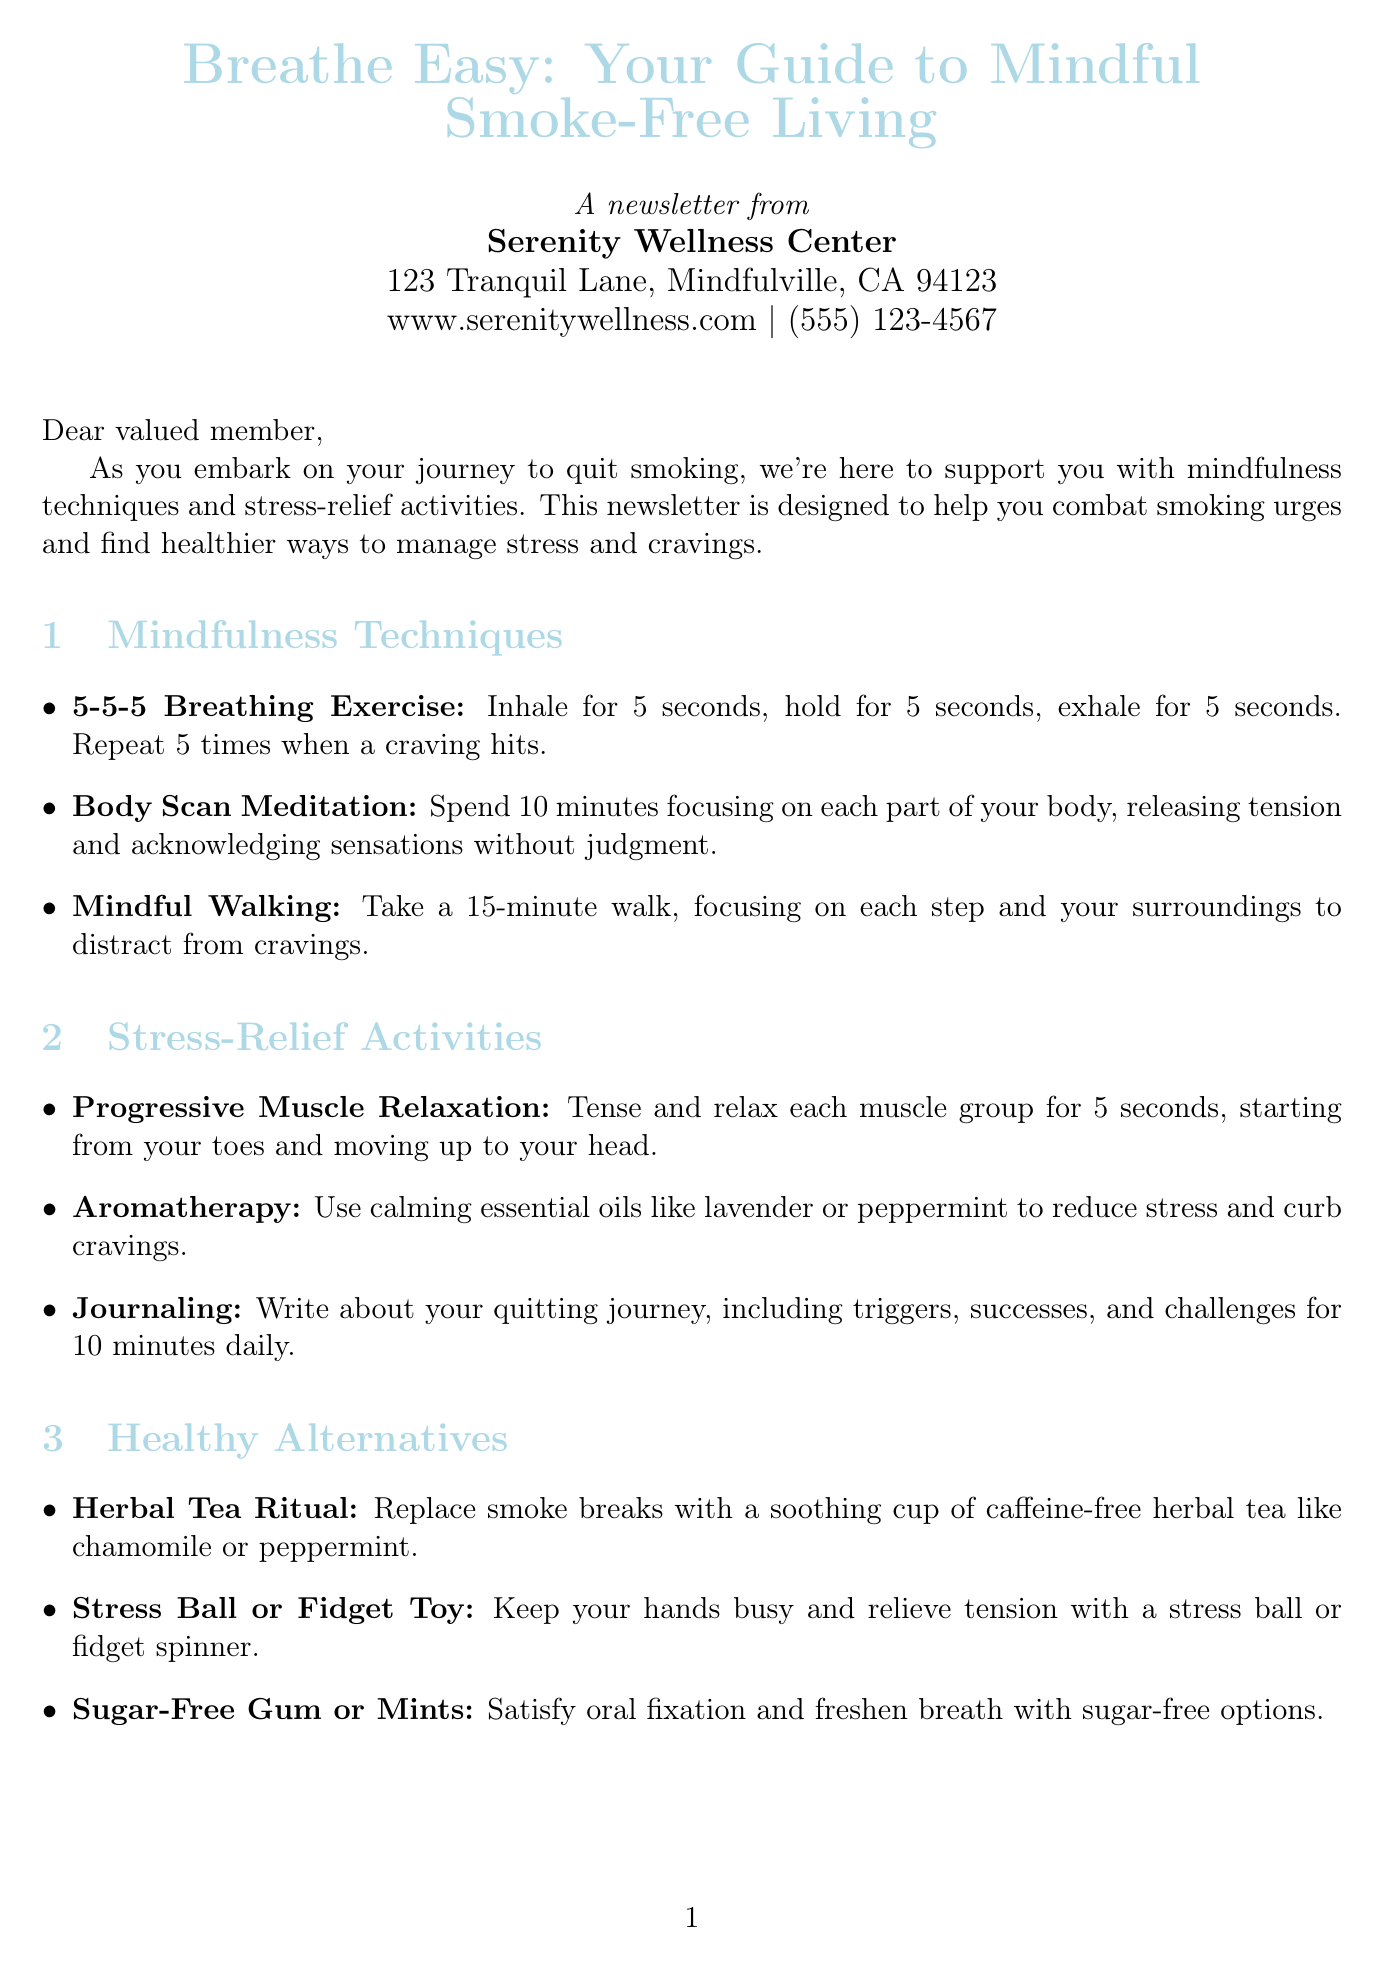What is the title of the newsletter? The title of the newsletter is mentioned at the beginning of the document.
Answer: Breathe Easy: Your Guide to Mindful Smoke-Free Living Who is the editor of the newsletter? The document identifies the editor's name and title.
Answer: Dr. Emma Thompson What is the location of the Serenity Wellness Center? The address of the center is provided in the document.
Answer: 123 Tranquil Lane, Mindfulville, CA 94123 What is the frequency of the Quit Smoking Support Group? The document states how often the support group meets.
Answer: Every Tuesday What activity is suggested to replace smoke breaks? The document lists healthier alternatives to smoking.
Answer: Herbal Tea Ritual Which breathing exercise is mentioned first? The mindfulness techniques are listed in the document, and the first one is specified.
Answer: 5-5-5 Breathing Exercise On which day and time is the Stress-Relief Yoga Class held? This detail can be found in the section about upcoming events.
Answer: Mondays and Thursdays at 6:00 PM What is the quote of the month? The document includes a motivational quote.
Answer: "The secret of change is to focus all of your energy not on fighting the old, but on building the new." What is the phone number for Serenity Wellness Center? The contact number is provided in the center's information.
Answer: (555) 123-4567 What essential oil is suggested for aromatherapy? The document specifies calming essential oils that can help reduce stress.
Answer: Lavender or peppermint 